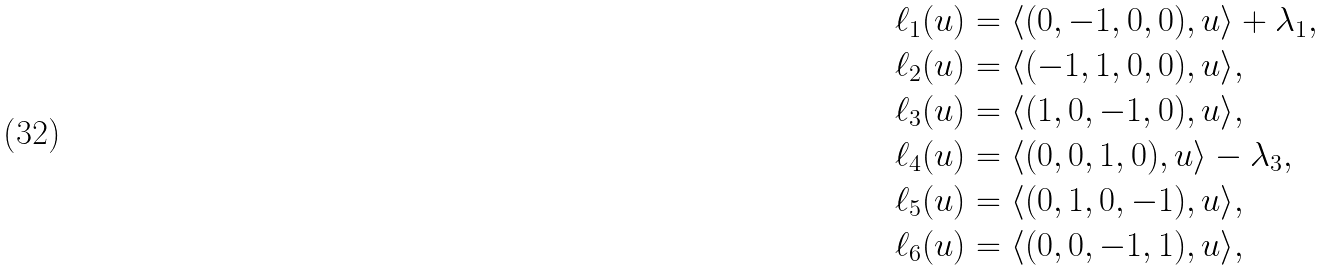Convert formula to latex. <formula><loc_0><loc_0><loc_500><loc_500>\ell _ { 1 } ( u ) & = \langle ( 0 , - 1 , 0 , 0 ) , u \rangle + \lambda _ { 1 } , \\ \ell _ { 2 } ( u ) & = \langle ( - 1 , 1 , 0 , 0 ) , u \rangle , \\ \ell _ { 3 } ( u ) & = \langle ( 1 , 0 , - 1 , 0 ) , u \rangle , \\ \ell _ { 4 } ( u ) & = \langle ( 0 , 0 , 1 , 0 ) , u \rangle - \lambda _ { 3 } , \\ \ell _ { 5 } ( u ) & = \langle ( 0 , 1 , 0 , - 1 ) , u \rangle , \\ \ell _ { 6 } ( u ) & = \langle ( 0 , 0 , - 1 , 1 ) , u \rangle ,</formula> 